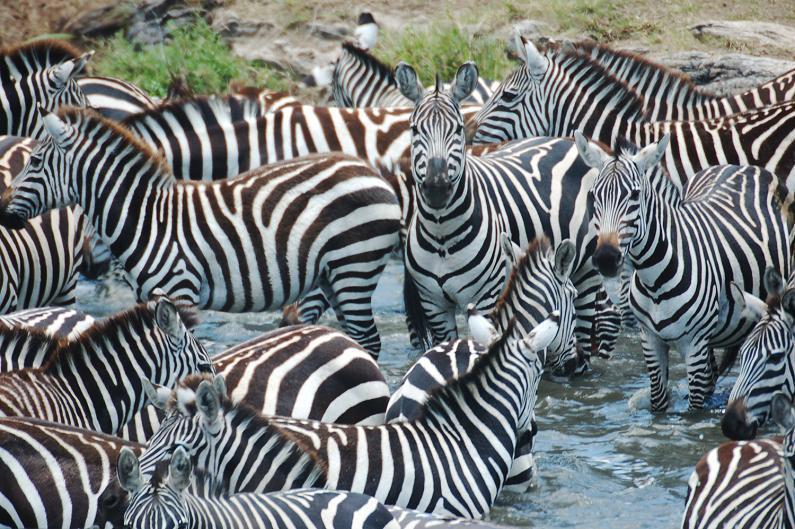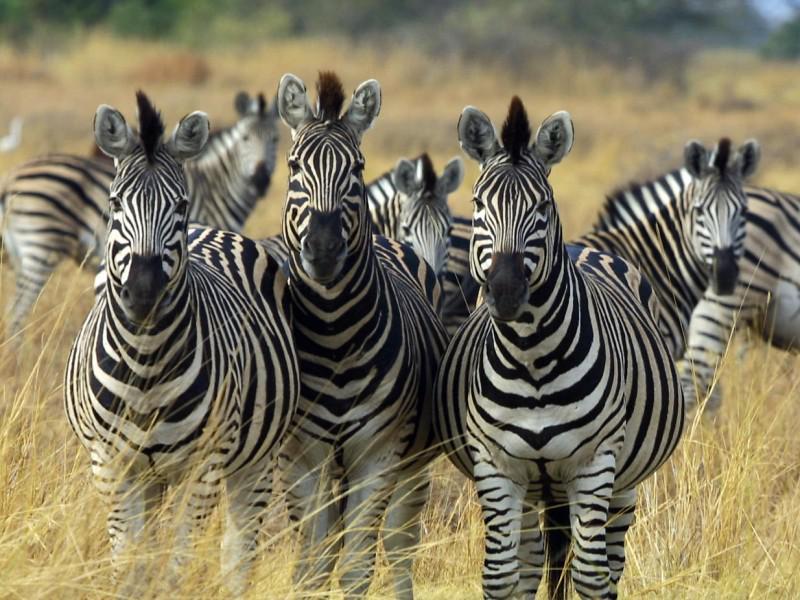The first image is the image on the left, the second image is the image on the right. Assess this claim about the two images: "One image shows multiple zebras standing in water up to their knees, and the other image shows multiple zebras standing on dry ground.". Correct or not? Answer yes or no. Yes. The first image is the image on the left, the second image is the image on the right. Analyze the images presented: Is the assertion "One image shows zebras in water and the other image shows zebras on grassland." valid? Answer yes or no. Yes. 